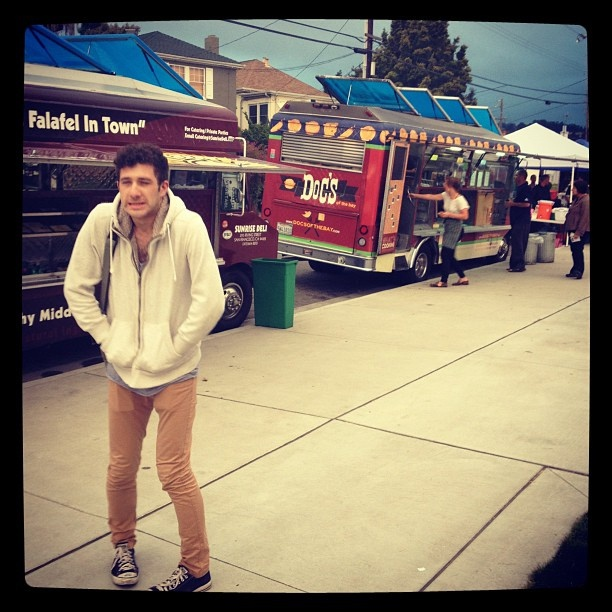Describe the objects in this image and their specific colors. I can see people in black, khaki, brown, and tan tones, truck in black, gray, brown, and navy tones, truck in black, navy, purple, gray, and khaki tones, bus in black, gray, and brown tones, and people in black, gray, brown, and purple tones in this image. 